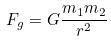<formula> <loc_0><loc_0><loc_500><loc_500>F _ { g } = G \frac { m _ { 1 } m _ { 2 } } { r ^ { 2 } }</formula> 